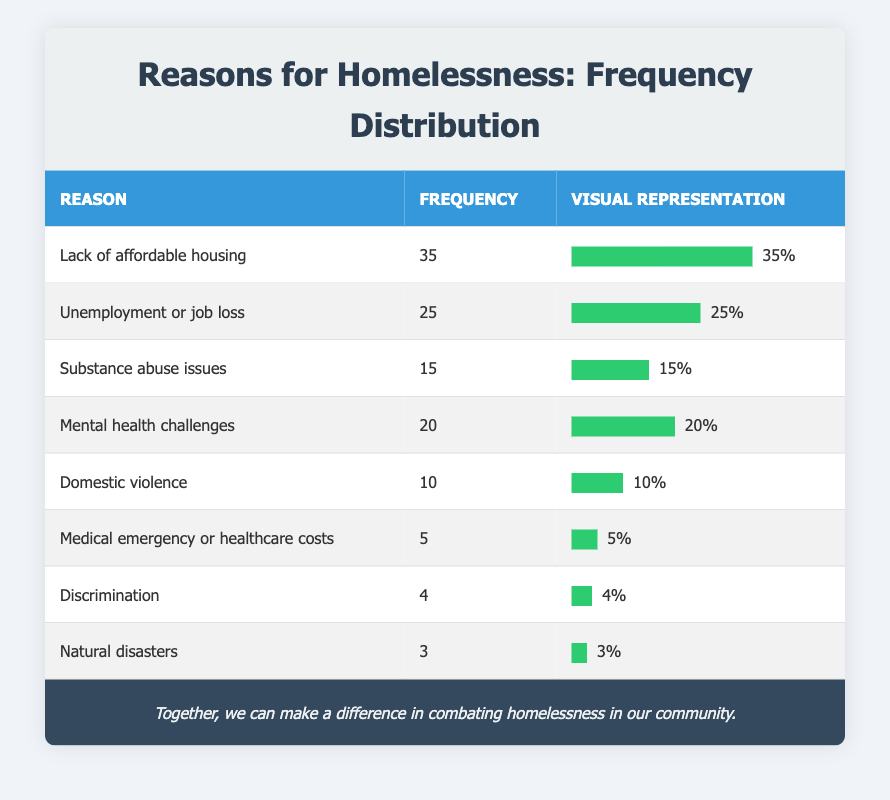What is the most common reason for homelessness reported in the table? The table lists the reasons for homelessness and their corresponding frequencies. The highest frequency is 35 for "Lack of affordable housing."
Answer: Lack of affordable housing What is the total frequency of reasons related to mental health and substance abuse? The table shows that the frequency for "Mental health challenges" is 20 and for "Substance abuse issues" is 15. Adding these together gives 20 + 15 = 35.
Answer: 35 Is domestic violence cited more often than medical emergencies as a reason for homelessness? The table indicates that "Domestic violence" has a frequency of 10 and "Medical emergency or healthcare costs" has a frequency of 5. Since 10 is greater than 5, the answer is yes.
Answer: Yes What proportion of the total reported reasons for homelessness does "Unemployment or job loss" represent? First, we sum all the frequencies: 35 + 25 + 15 + 20 + 10 + 5 + 4 + 3 = 117. "Unemployment or job loss" has a frequency of 25. To find the proportion, we calculate 25 / 117 which is approximately 0.214 or 21.4%.
Answer: Approximately 21.4% How many reasons for homelessness have a frequency of less than 10? By examining the table, we see that "Medical emergency or healthcare costs" (5), "Discrimination" (4), and "Natural disasters" (3) each have frequencies less than 10. This gives us a total of 3 reasons.
Answer: 3 What is the difference in frequency between the most and least common reasons for homelessness? The most common reason is "Lack of affordable housing" with a frequency of 35. The least common reason is "Natural disasters" with a frequency of 3. The difference is 35 - 3 = 32.
Answer: 32 Are there more reasons related to personal issues like substance abuse and mental health than external factors like natural disasters? The table shows that personal issues (substance abuse: 15, mental health: 20) total to 35. The external factor "Natural disasters" has a frequency of 3. Since 35 is greater than 3, the answer is yes.
Answer: Yes What is the average frequency of the reasons listed in the table? To find the average, sum all the frequencies (117) and divide by the number of reasons (8). So the average is 117 / 8 = 14.625, which can be rounded to 15 for simplicity.
Answer: 15 